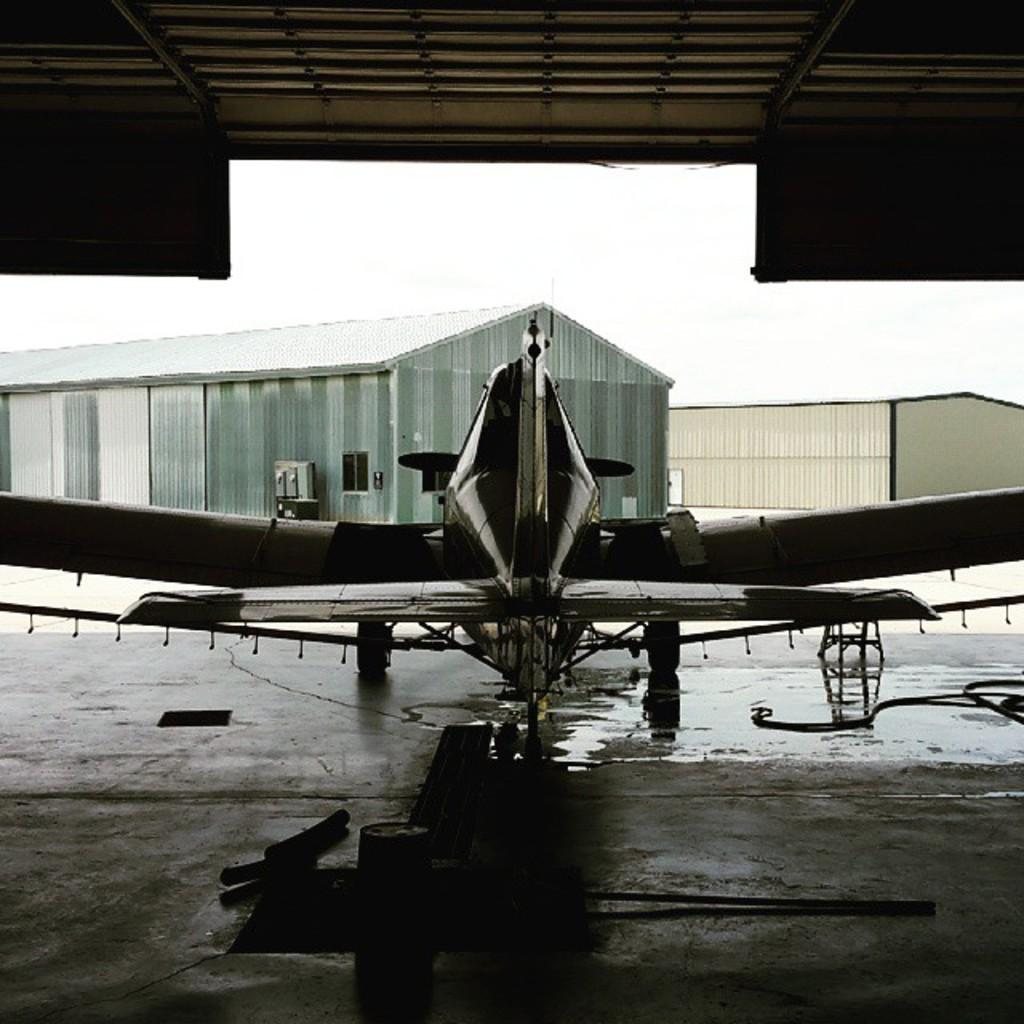What is the main object on the floor at the bottom of the image? There is a plane on the floor at the bottom of the image. What structures are in front of the plane? There are sheds in front of the plane. What is visible at the top of the image? There is a ceiling visible at the top of the image. Can you describe any other objects in the image? There are other unspecified objects in the image. What type of straw is being used to clam up the burst pipe in the image? There is no straw, clam, or burst pipe present in the image. 